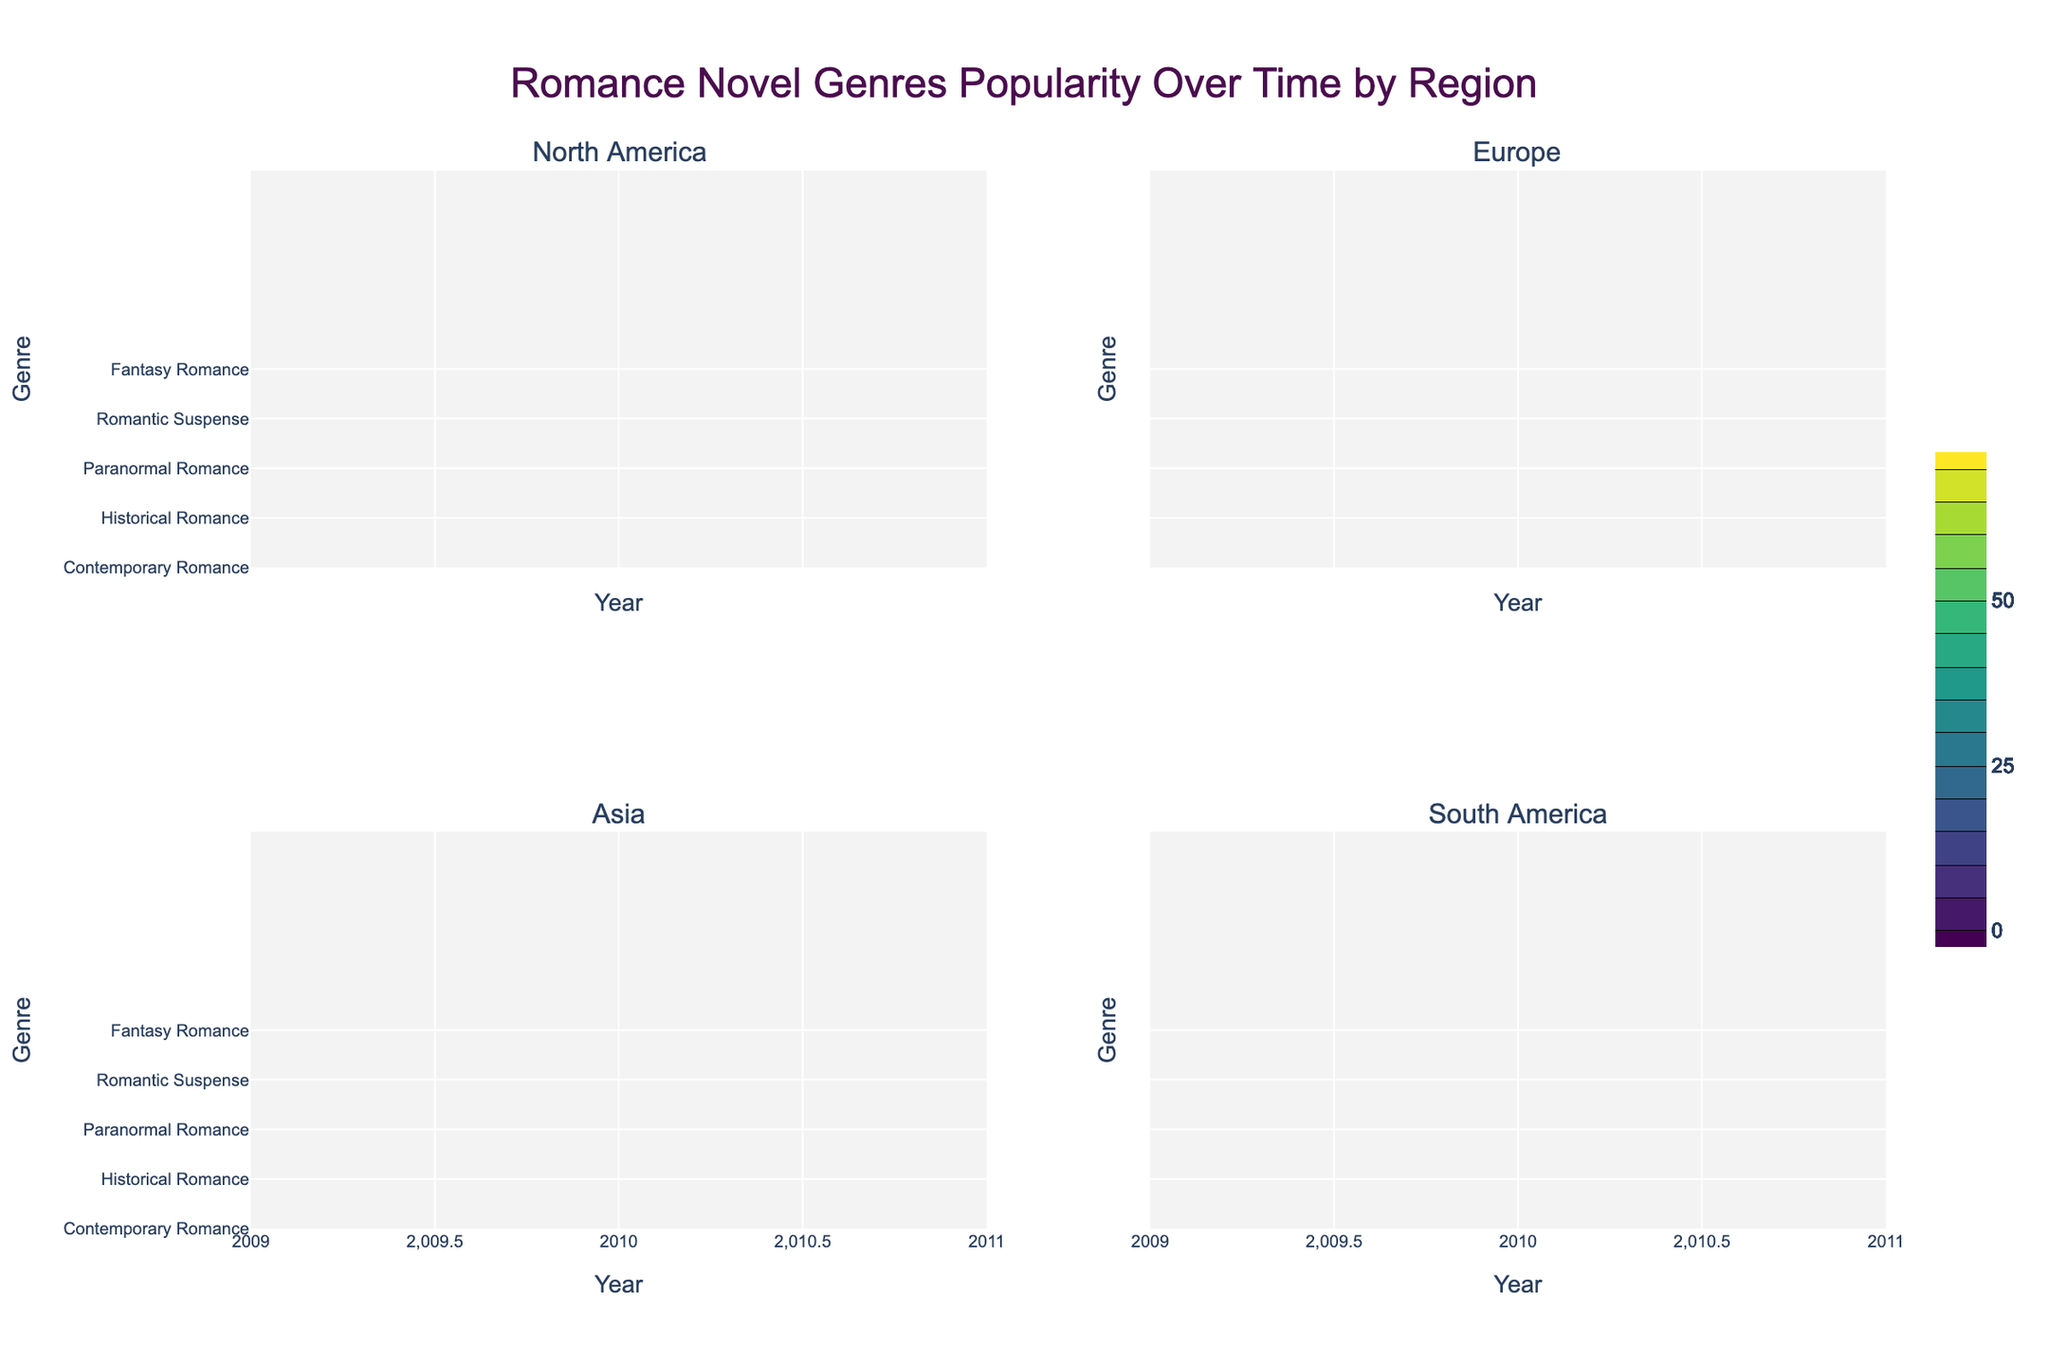What is the title of the figure? The title is typically located at the top of the figure. In this case, it reads "Romance Novel Genres Popularity Over Time by Region".
Answer: Romance Novel Genres Popularity Over Time by Region Which region shows the highest popularity for Contemporary Romance in 2020? By examining the contour levels and labels for the year 2020 across all regions, we can determine that North America has the highest.
Answer: North America How does the popularity of Historical Romance change over time in Europe? Look at the contour levels for Historical Romance in the Europe subplot from 2010 to 2020. The levels show a decrease from 40 in 2010 to 28 in 2020.
Answer: It decreases Which genre in Asia had the most significant increase in popularity from 2010 to 2020? By comparing the contour levels for each genre in the Asia subplot, we see that Fantasy Romance increases from 18 in 2010 to 32 in 2020, which is the largest increase.
Answer: Fantasy Romance Compare the popularity of Romantic Suspense in South America and North America in 2016. Locate the contour levels for Romantic Suspense in 2016 for both regions. North America has a value of 40, while South America has a value of 28.
Answer: Higher in North America What is the overall trend of Paranormal Romance genre popularity in all regions? For each region subplot, the contour levels for Paranormal Romance can be tracked from 2010 to 2020. It generally increases in all regions, though at different rates.
Answer: Increasing Which region has the least variation in the popularity of Fantasy Romance over the years? Examine the contour levels for Fantasy Romance in each regional subplot. North America shows a gradual increase, suggesting less variation compared to others which have more fluctuations.
Answer: North America What was the popularity of Contemporary Romance in Europe in 2018? Find the contour level corresponding to Contemporary Romance in Europe for the year 2018. It shows a value of 50.
Answer: 50 Between which years did Paranormal Romance gain popularity the fastest in North America? Focus on the contour levels for Paranormal Romance in North America. The increase is fastest between 2016 and 2018 (22 to 25).
Answer: 2016 to 2018 Compare the starting popularity (2010) of Historical Romance in Asia and South America. Which had a higher value? Find the 2010 contour levels for Historical Romance in both Asia and South America. Asia has a higher value at 35, compared to South America at 25.
Answer: Asia 